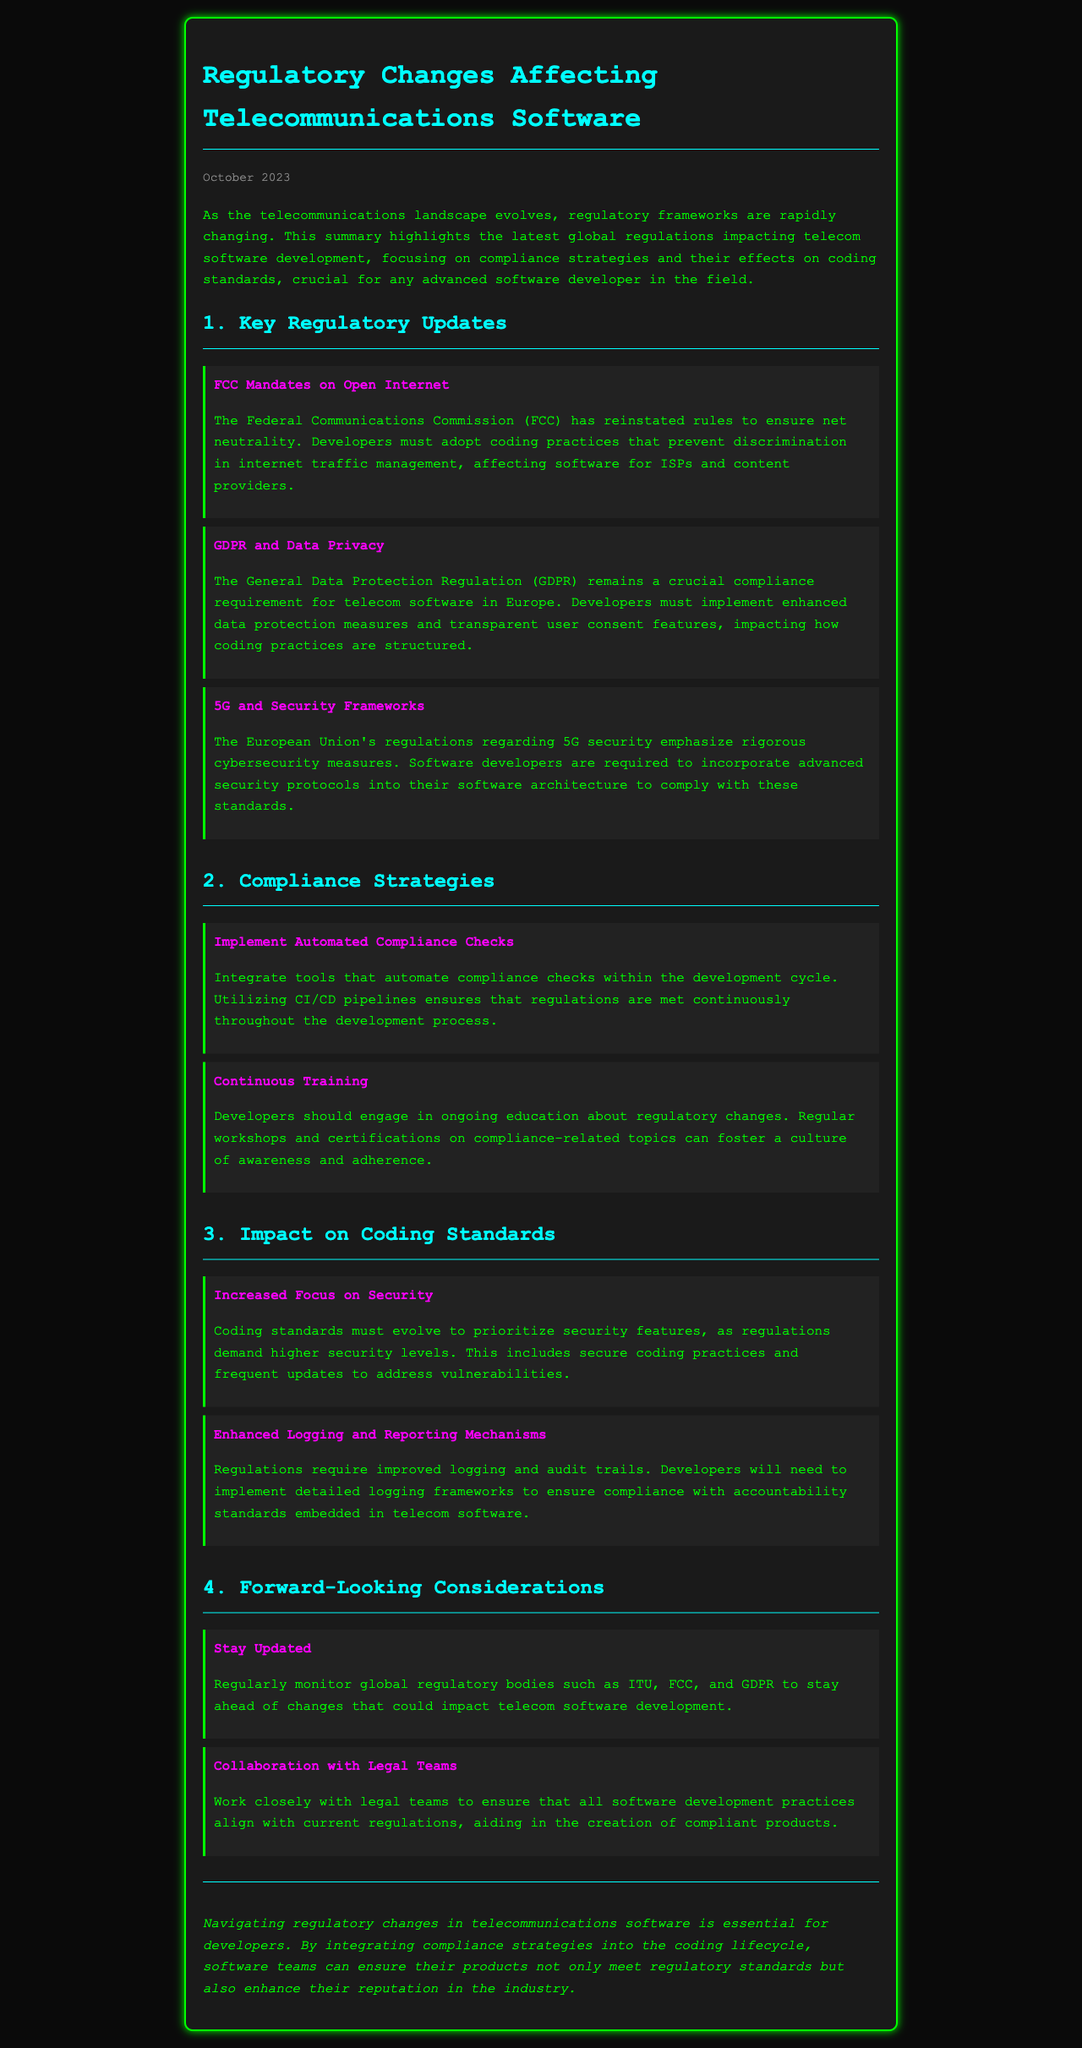What is the date of the newsletter? The date is prominently mentioned at the top of the newsletter as October 2023.
Answer: October 2023 What regulation emphasizes net neutrality? The regulation specifically mentioned regarding net neutrality is a mandate from the Federal Communications Commission (FCC).
Answer: FCC Mandates on Open Internet Which regulation focuses on data privacy in Europe? The data privacy regulation discussed in the document is the General Data Protection Regulation (GDPR).
Answer: GDPR What should developers implement for 5G compliance? Developers are required to incorporate advanced security protocols into their software architecture for compliance with 5G regulations.
Answer: Advanced security protocols What is a recommended compliance strategy mentioned in the newsletter? One of the recommended compliance strategies is to implement automated compliance checks within the development cycle.
Answer: Automated compliance checks Which organizations should developers monitor for regulatory changes? Developers should regularly monitor global regulatory bodies such as ITU, FCC, and GDPR.
Answer: ITU, FCC, and GDPR What type of training should developers engage in? Developers should engage in ongoing education about regulatory changes.
Answer: Ongoing education What is the impact of regulations on coding standards according to the newsletter? Regulations demand that coding standards evolve to prioritize security features as well as enhanced logging and reporting.
Answer: Prioritize security features Which section discusses forward-looking considerations? The section that discusses forward-looking considerations is titled "4. Forward-Looking Considerations."
Answer: 4. Forward-Looking Considerations 